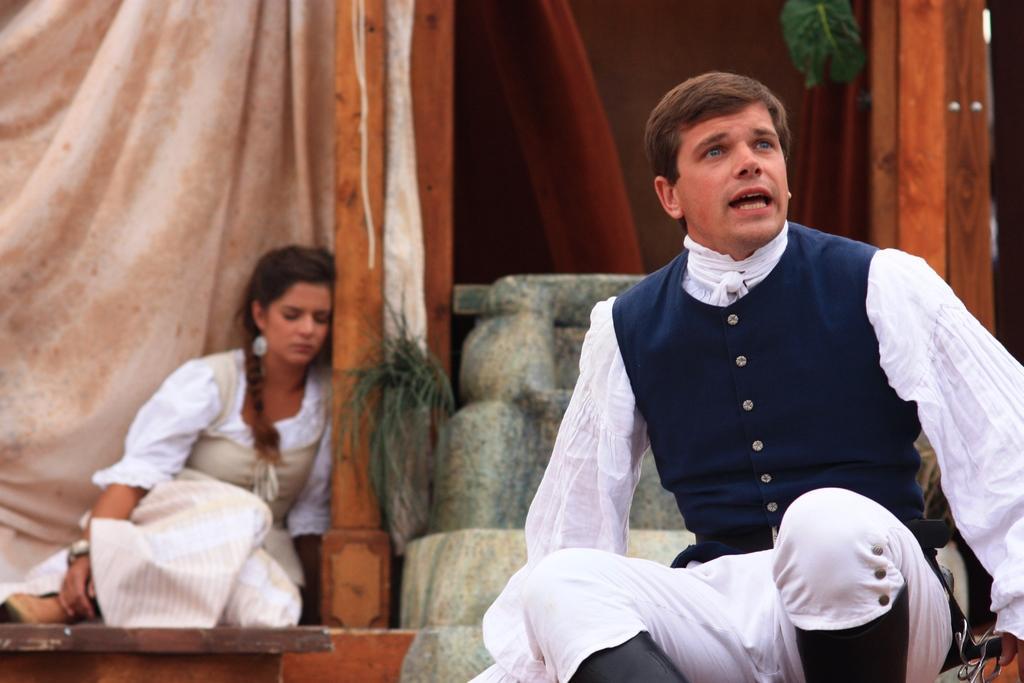In one or two sentences, can you explain what this image depicts? In this image, on the right there is a man, he is sitting. On the left there is a woman, she is sitting. This seems like a stage drama. In the background there are curtains, door, stones. 